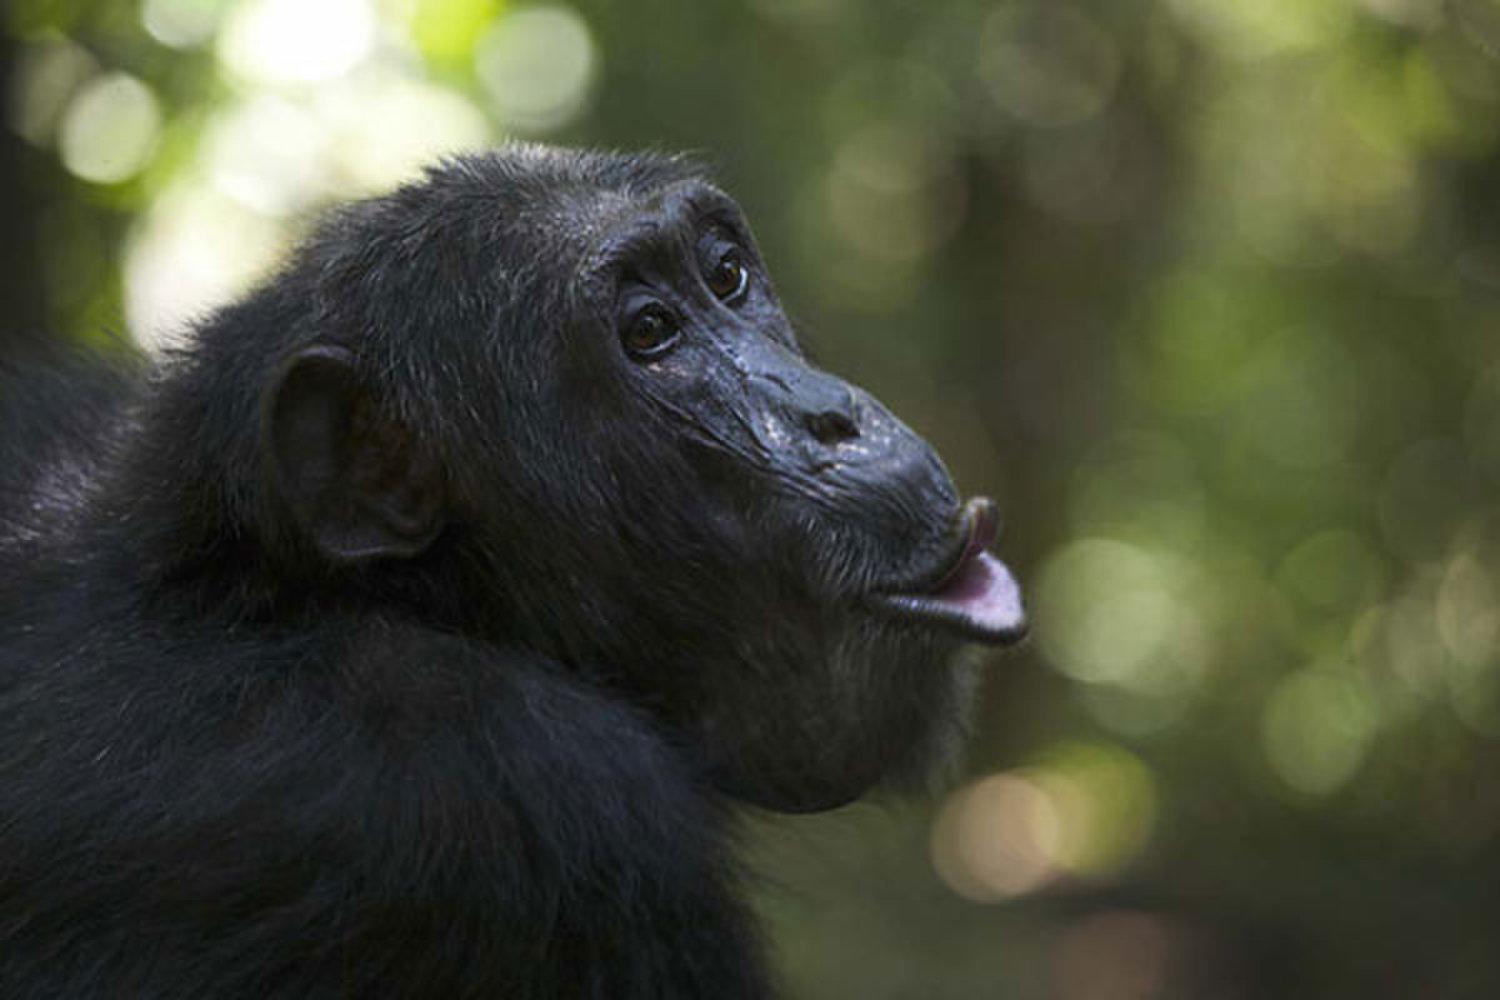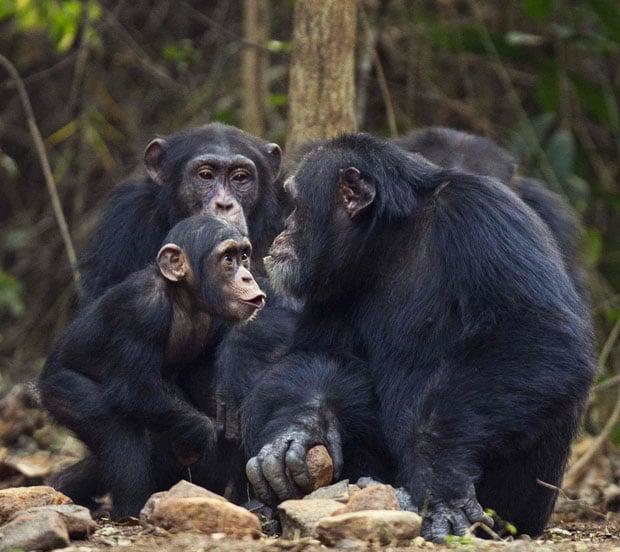The first image is the image on the left, the second image is the image on the right. Considering the images on both sides, is "The right image contains exactly two chimpanzees." valid? Answer yes or no. No. The first image is the image on the left, the second image is the image on the right. Examine the images to the left and right. Is the description "Each image shows exactly two chimps sitting close together, and at least one image shows a chimp grooming the fur of the other." accurate? Answer yes or no. No. 